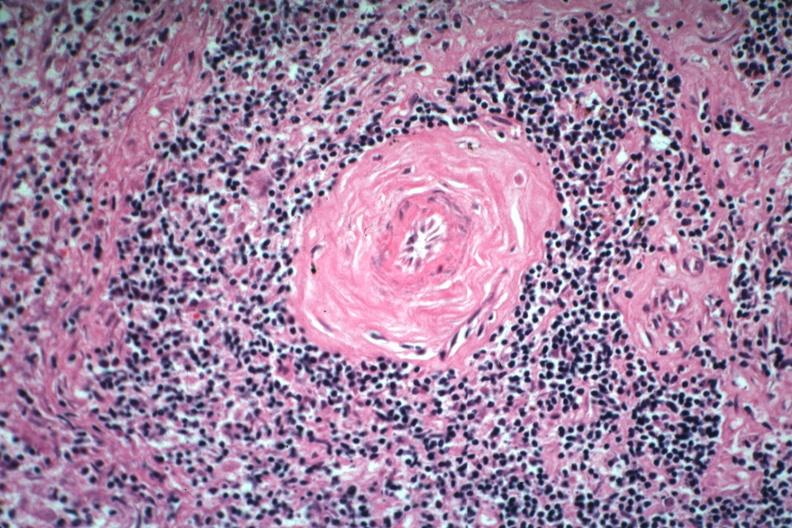what is present?
Answer the question using a single word or phrase. Spleen 